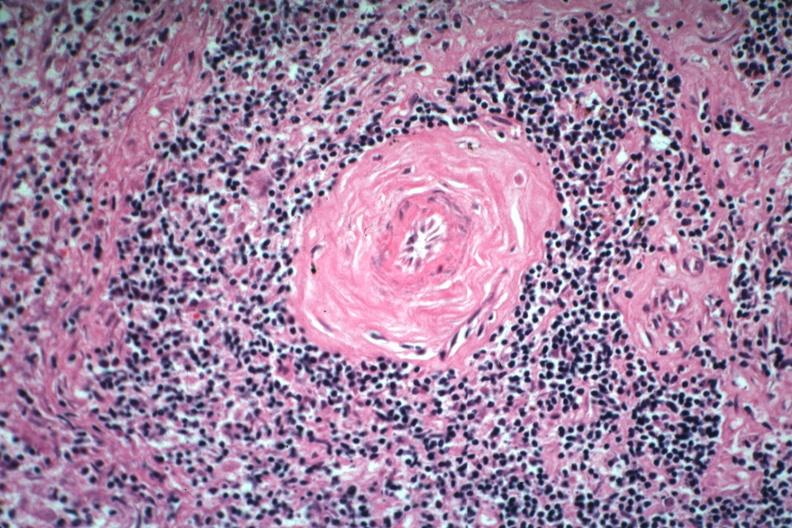what is present?
Answer the question using a single word or phrase. Spleen 